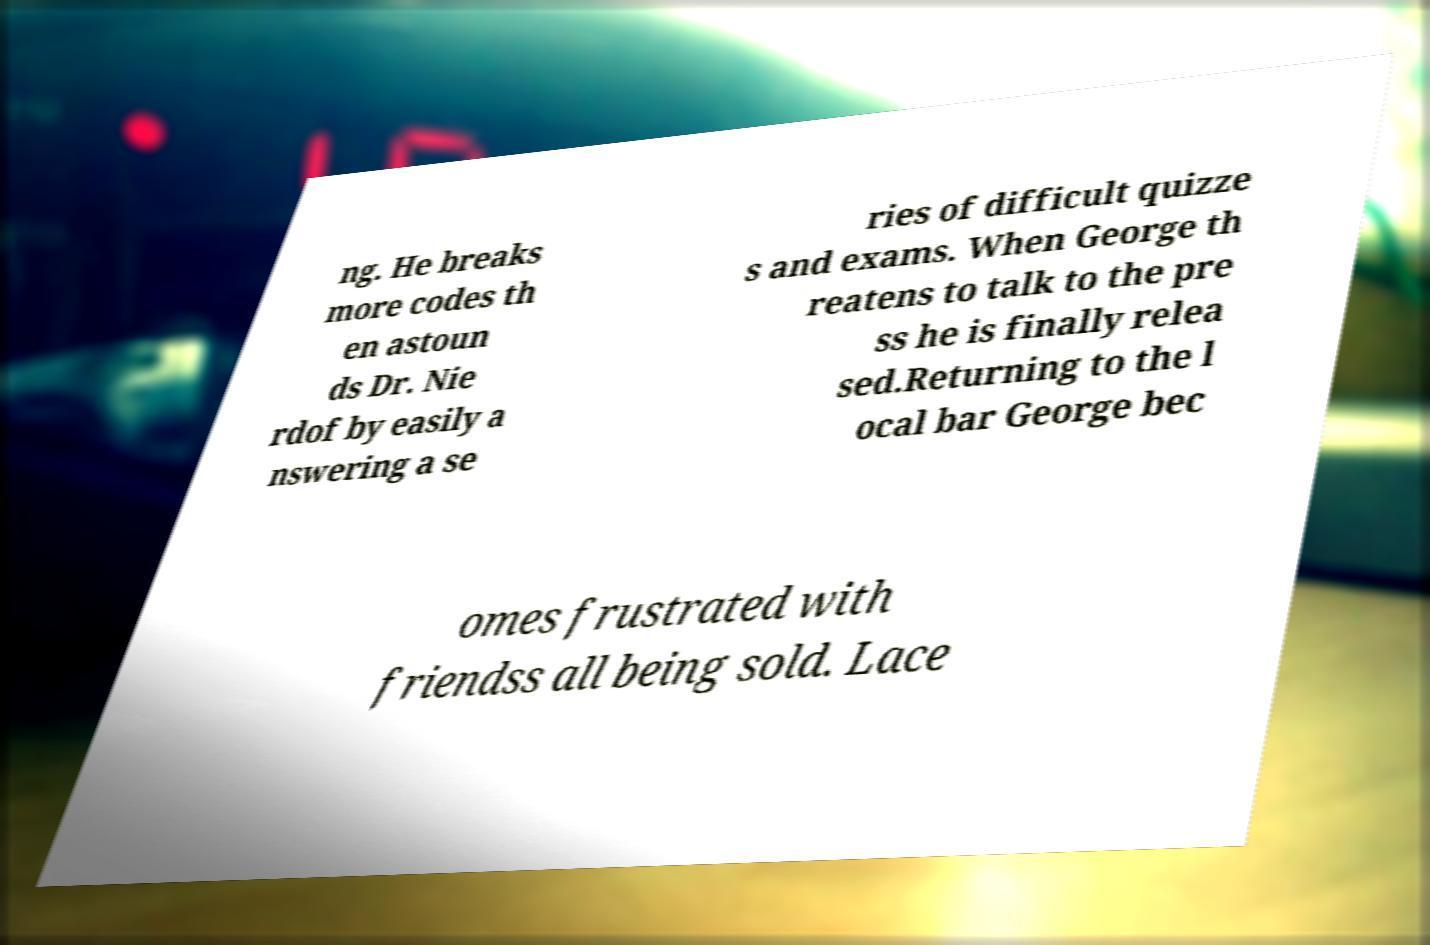Can you read and provide the text displayed in the image?This photo seems to have some interesting text. Can you extract and type it out for me? ng. He breaks more codes th en astoun ds Dr. Nie rdof by easily a nswering a se ries of difficult quizze s and exams. When George th reatens to talk to the pre ss he is finally relea sed.Returning to the l ocal bar George bec omes frustrated with friendss all being sold. Lace 